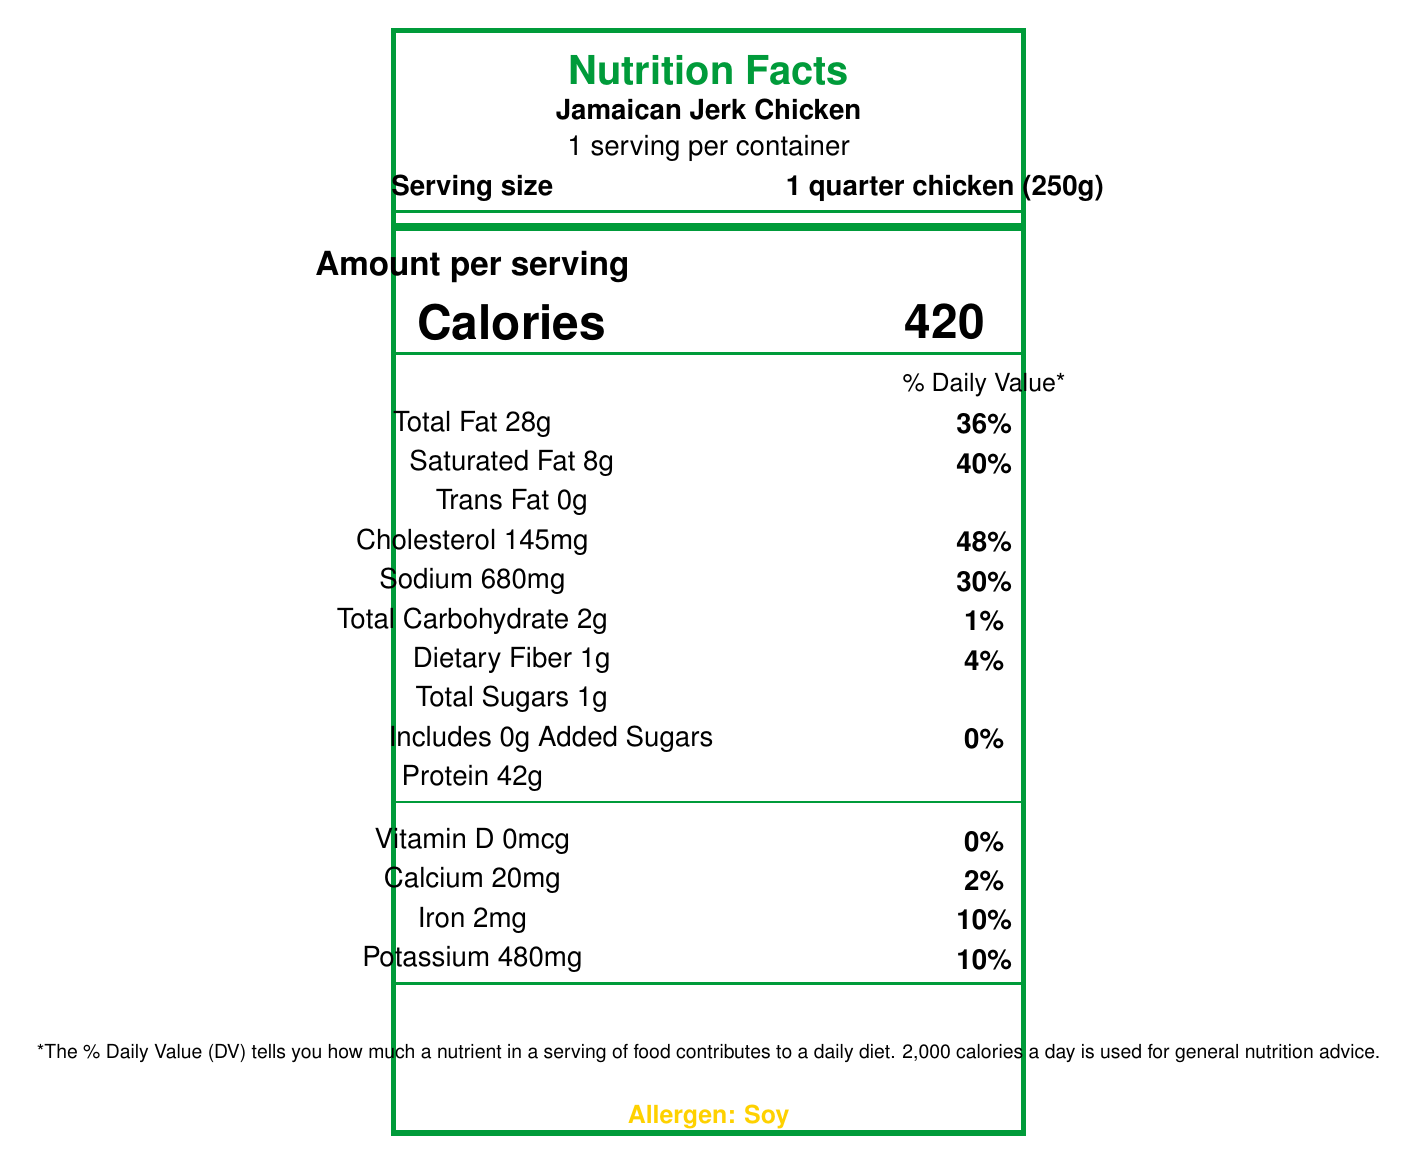What is the serving size of Jamaican Jerk Chicken listed in the document? The serving size is clearly indicated next to "Serving size" in the document.
Answer: 1 quarter chicken (250g) How many calories are there per serving of Jamaican Jerk Chicken? The document lists "Calories 420" in the section dedicated to the amount per serving.
Answer: 420 What percentage of the daily value of sodium does one serving of Jamaican Jerk Chicken provide? Next to "Sodium 680mg", the document specifies 30% as the daily value.
Answer: 30% How much protein is in one serving of Jamaican Jerk Chicken? The amount of protein is listed near the bottom of the nutrient section as "Protein 42g".
Answer: 42g How much total fat is in one serving? Total Fat is listed as 28g with a daily value percentage of 36%.
Answer: 28g What are the key ingredients of Jamaican Jerk Chicken mentioned? The ingredients are provided in the cultural significance section of the document.
Answer: Chicken, Scotch bonnet peppers, allspice berries, thyme, garlic, ginger, brown sugar, soy sauce, vegetable oil, salt, black pepper What is the daily value percentage for saturated fat for one serving? A. 20% B. 36% C. 40% D. 48% The document states "Saturated Fat 8g" with a daily value percentage of 40%.
Answer: C. 40% How many grams of dietary fiber are in a serving of Jamaican Jerk Chicken? The amount of dietary fiber is listed as "Dietary Fiber 1g" with a daily value of 4%.
Answer: 1g Which vitamin has a daily value percentage of 0% in one serving? A. Vitamin D B. Calcium C. Iron D. Potassium The document specifies that "Vitamin D 0mcg" has a daily value of 0%.
Answer: A. Vitamin D Does the Jamaican Jerk Chicken contain any trans fat? The document states "Trans Fat 0g".
Answer: No What is the iron content in one serving? The iron content is listed as "Iron 2mg" with a daily value percentage of 10%.
Answer: 2mg Is there any added sugar in Jamaican Jerk Chicken? The document indicates "Includes 0g Added Sugars" which means there is no added sugar.
Answer: No What is the allergen listed in the document? The document highlights "Allergen: Soy" at the bottom.
Answer: Soy Summarize the information provided in the document. The document comprehensively lists the nutritional content per serving, important details about the dish's cultural importance, ingredients, allergen information, and preparation method. It also comments on the dish's role in contributing to cultural diversity and economic integration.
Answer: The document provides the nutrition facts for Jamaican Jerk Chicken, highlighting the serving size, calories, and various nutrients along with their daily values. It also mentions the cultural significance, key ingredients, allergens, preparation method, and the origin of the dish. Additionally, it discusses the relevance of Jamaican Jerk Chicken to immigration and policy considerations. What time of the year is Jamaican Jerk Chicken most commonly consumed? The document does not provide any information about the season or time of the year when Jamaican Jerk Chicken is most commonly consumed.
Answer: Cannot be determined 